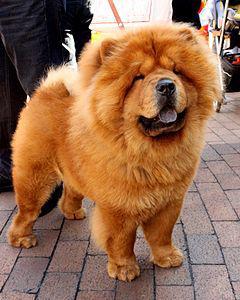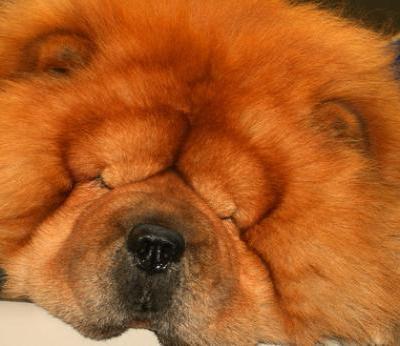The first image is the image on the left, the second image is the image on the right. Assess this claim about the two images: "One image features a chow standing on a red brick-colored surface and looking upward.". Correct or not? Answer yes or no. Yes. The first image is the image on the left, the second image is the image on the right. Considering the images on both sides, is "A single dog is lying down in the image on the right." valid? Answer yes or no. Yes. 